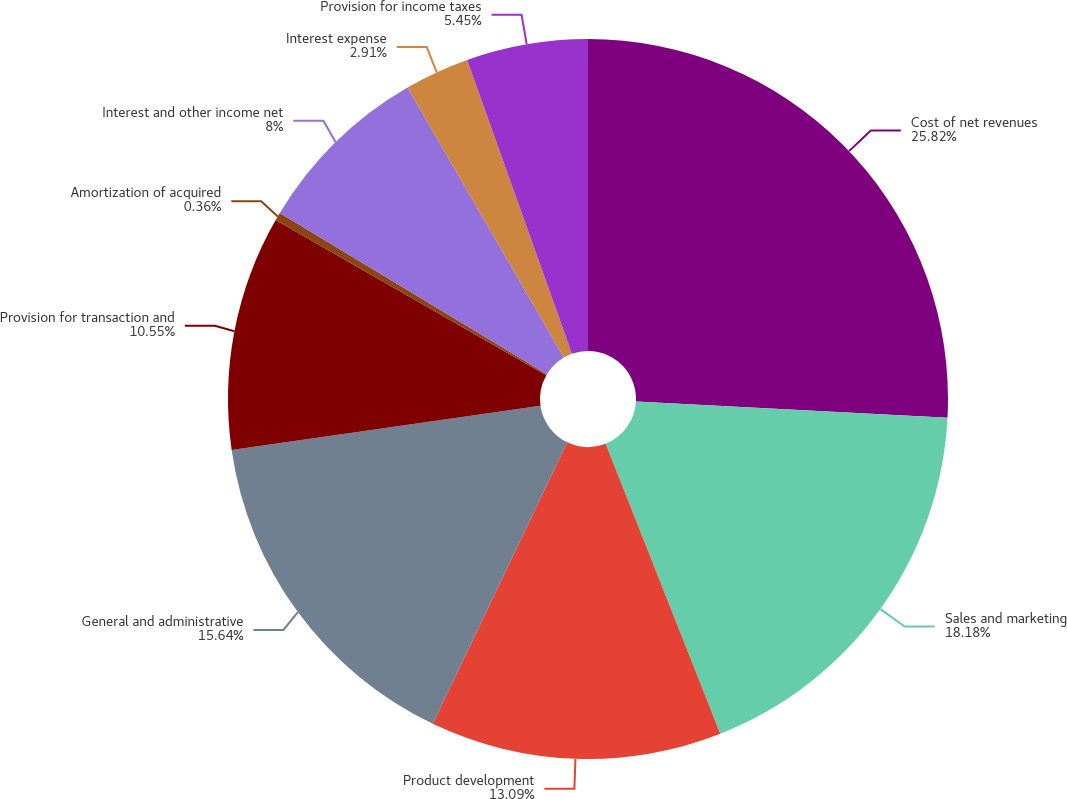Convert chart to OTSL. <chart><loc_0><loc_0><loc_500><loc_500><pie_chart><fcel>Cost of net revenues<fcel>Sales and marketing<fcel>Product development<fcel>General and administrative<fcel>Provision for transaction and<fcel>Amortization of acquired<fcel>Interest and other income net<fcel>Interest expense<fcel>Provision for income taxes<nl><fcel>25.83%<fcel>18.19%<fcel>13.09%<fcel>15.64%<fcel>10.55%<fcel>0.36%<fcel>8.0%<fcel>2.91%<fcel>5.45%<nl></chart> 